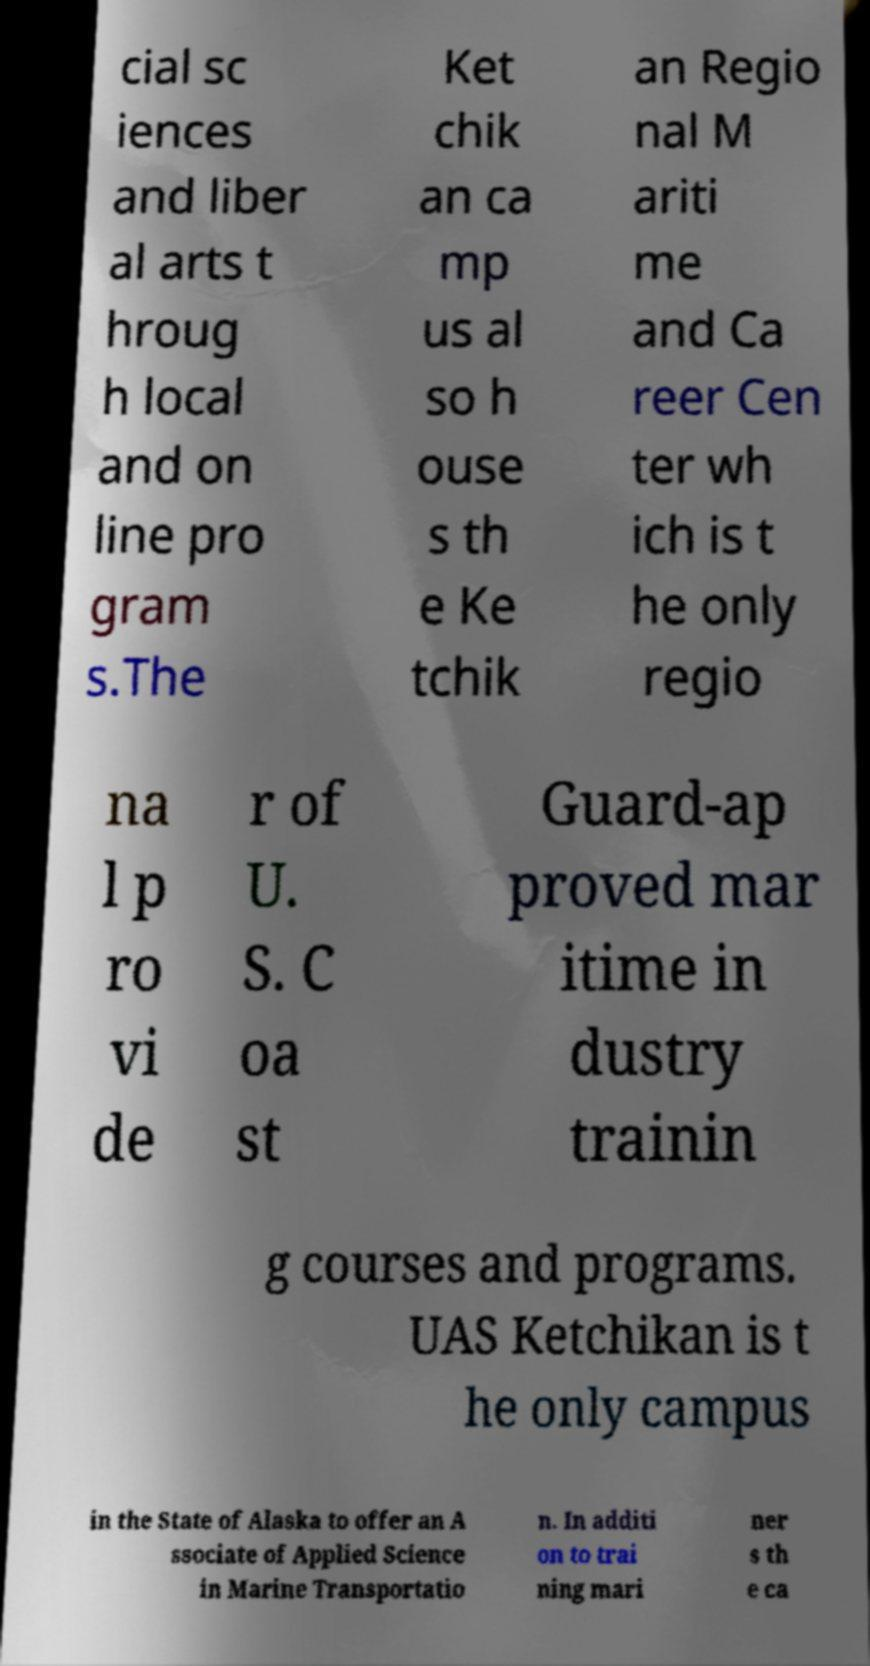Can you read and provide the text displayed in the image?This photo seems to have some interesting text. Can you extract and type it out for me? cial sc iences and liber al arts t hroug h local and on line pro gram s.The Ket chik an ca mp us al so h ouse s th e Ke tchik an Regio nal M ariti me and Ca reer Cen ter wh ich is t he only regio na l p ro vi de r of U. S. C oa st Guard-ap proved mar itime in dustry trainin g courses and programs. UAS Ketchikan is t he only campus in the State of Alaska to offer an A ssociate of Applied Science in Marine Transportatio n. In additi on to trai ning mari ner s th e ca 